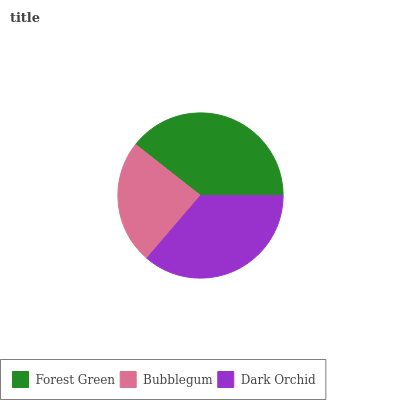Is Bubblegum the minimum?
Answer yes or no. Yes. Is Forest Green the maximum?
Answer yes or no. Yes. Is Dark Orchid the minimum?
Answer yes or no. No. Is Dark Orchid the maximum?
Answer yes or no. No. Is Dark Orchid greater than Bubblegum?
Answer yes or no. Yes. Is Bubblegum less than Dark Orchid?
Answer yes or no. Yes. Is Bubblegum greater than Dark Orchid?
Answer yes or no. No. Is Dark Orchid less than Bubblegum?
Answer yes or no. No. Is Dark Orchid the high median?
Answer yes or no. Yes. Is Dark Orchid the low median?
Answer yes or no. Yes. Is Forest Green the high median?
Answer yes or no. No. Is Forest Green the low median?
Answer yes or no. No. 